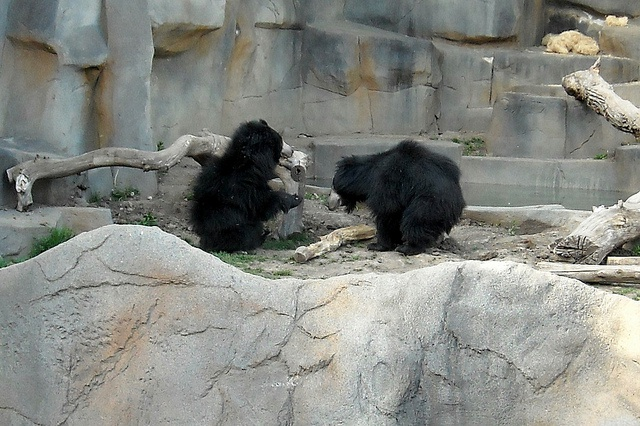Describe the objects in this image and their specific colors. I can see bear in gray, black, and darkgray tones and bear in gray, black, and darkgray tones in this image. 